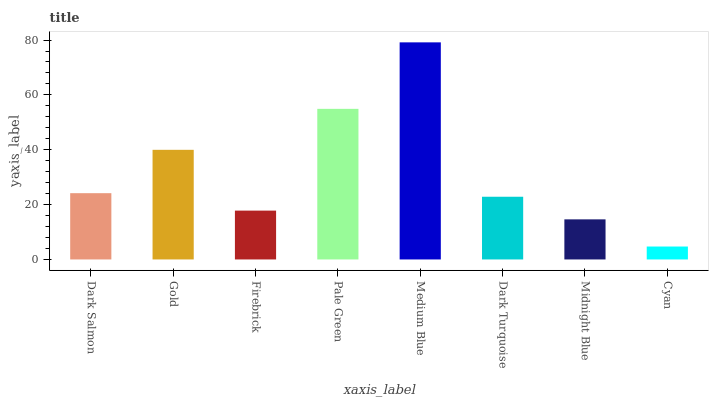Is Gold the minimum?
Answer yes or no. No. Is Gold the maximum?
Answer yes or no. No. Is Gold greater than Dark Salmon?
Answer yes or no. Yes. Is Dark Salmon less than Gold?
Answer yes or no. Yes. Is Dark Salmon greater than Gold?
Answer yes or no. No. Is Gold less than Dark Salmon?
Answer yes or no. No. Is Dark Salmon the high median?
Answer yes or no. Yes. Is Dark Turquoise the low median?
Answer yes or no. Yes. Is Pale Green the high median?
Answer yes or no. No. Is Pale Green the low median?
Answer yes or no. No. 